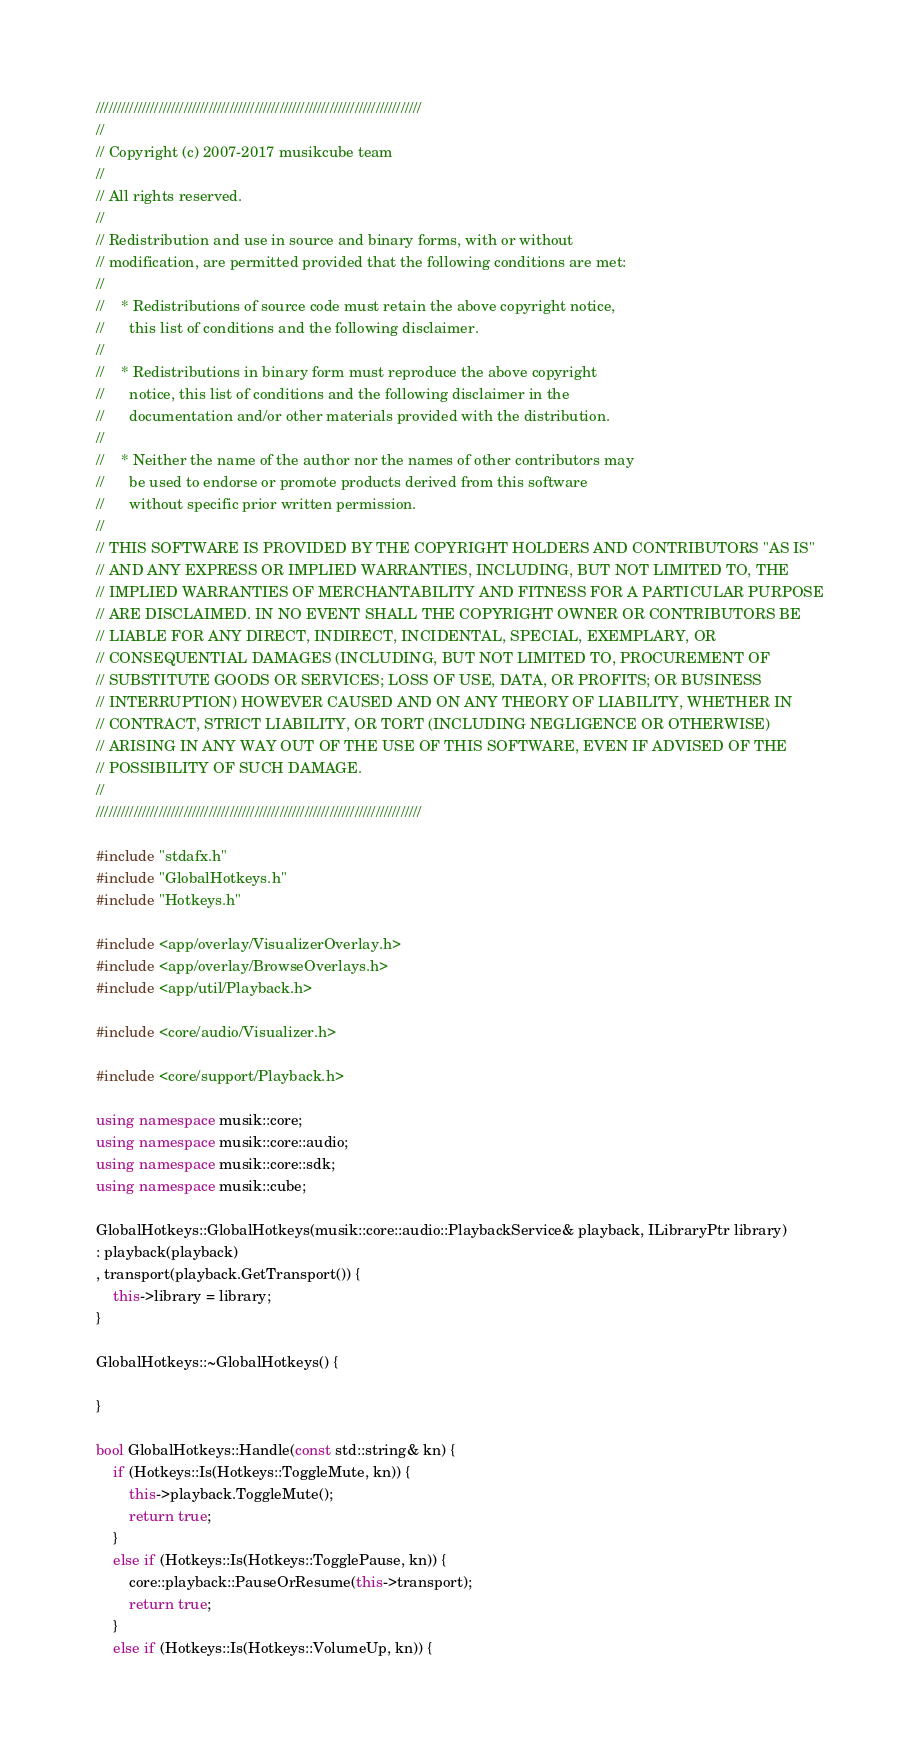<code> <loc_0><loc_0><loc_500><loc_500><_C++_>//////////////////////////////////////////////////////////////////////////////
//
// Copyright (c) 2007-2017 musikcube team
//
// All rights reserved.
//
// Redistribution and use in source and binary forms, with or without
// modification, are permitted provided that the following conditions are met:
//
//    * Redistributions of source code must retain the above copyright notice,
//      this list of conditions and the following disclaimer.
//
//    * Redistributions in binary form must reproduce the above copyright
//      notice, this list of conditions and the following disclaimer in the
//      documentation and/or other materials provided with the distribution.
//
//    * Neither the name of the author nor the names of other contributors may
//      be used to endorse or promote products derived from this software
//      without specific prior written permission.
//
// THIS SOFTWARE IS PROVIDED BY THE COPYRIGHT HOLDERS AND CONTRIBUTORS "AS IS"
// AND ANY EXPRESS OR IMPLIED WARRANTIES, INCLUDING, BUT NOT LIMITED TO, THE
// IMPLIED WARRANTIES OF MERCHANTABILITY AND FITNESS FOR A PARTICULAR PURPOSE
// ARE DISCLAIMED. IN NO EVENT SHALL THE COPYRIGHT OWNER OR CONTRIBUTORS BE
// LIABLE FOR ANY DIRECT, INDIRECT, INCIDENTAL, SPECIAL, EXEMPLARY, OR
// CONSEQUENTIAL DAMAGES (INCLUDING, BUT NOT LIMITED TO, PROCUREMENT OF
// SUBSTITUTE GOODS OR SERVICES; LOSS OF USE, DATA, OR PROFITS; OR BUSINESS
// INTERRUPTION) HOWEVER CAUSED AND ON ANY THEORY OF LIABILITY, WHETHER IN
// CONTRACT, STRICT LIABILITY, OR TORT (INCLUDING NEGLIGENCE OR OTHERWISE)
// ARISING IN ANY WAY OUT OF THE USE OF THIS SOFTWARE, EVEN IF ADVISED OF THE
// POSSIBILITY OF SUCH DAMAGE.
//
//////////////////////////////////////////////////////////////////////////////

#include "stdafx.h"
#include "GlobalHotkeys.h"
#include "Hotkeys.h"

#include <app/overlay/VisualizerOverlay.h>
#include <app/overlay/BrowseOverlays.h>
#include <app/util/Playback.h>

#include <core/audio/Visualizer.h>

#include <core/support/Playback.h>

using namespace musik::core;
using namespace musik::core::audio;
using namespace musik::core::sdk;
using namespace musik::cube;

GlobalHotkeys::GlobalHotkeys(musik::core::audio::PlaybackService& playback, ILibraryPtr library)
: playback(playback)
, transport(playback.GetTransport()) {
    this->library = library;
}

GlobalHotkeys::~GlobalHotkeys() {

}

bool GlobalHotkeys::Handle(const std::string& kn) {
    if (Hotkeys::Is(Hotkeys::ToggleMute, kn)) {
        this->playback.ToggleMute();
        return true;
    }
    else if (Hotkeys::Is(Hotkeys::TogglePause, kn)) {
        core::playback::PauseOrResume(this->transport);
        return true;
    }
    else if (Hotkeys::Is(Hotkeys::VolumeUp, kn)) {</code> 